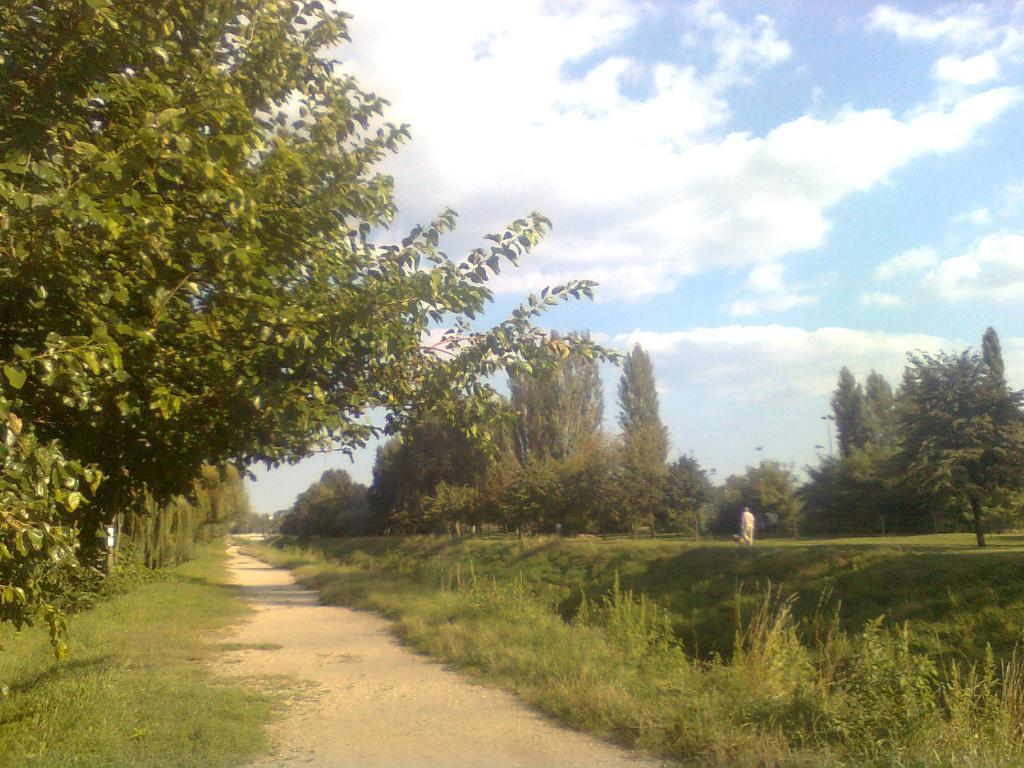What is the main feature of the image? There is a path in the image. What can be seen on either side of the path? There is green land and trees on either side of the path. What is visible in the background of the image? The sky is visible in the background of the image. What scientific experiment is being conducted on the path in the image? There is no indication of a scientific experiment being conducted in the image; it simply shows a path with green land and trees on either side. How many lines can be seen on the path in the image? The path itself is a single line, but there are no additional lines visible in the image. 